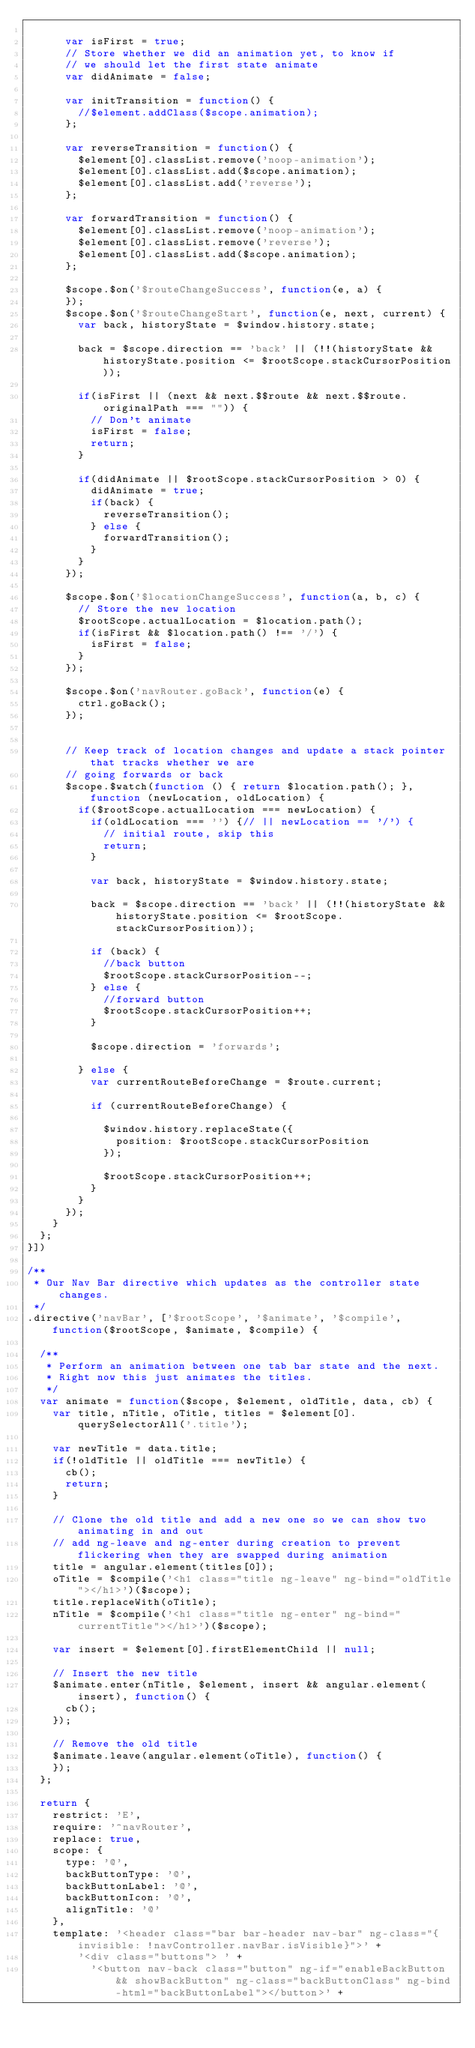Convert code to text. <code><loc_0><loc_0><loc_500><loc_500><_JavaScript_>
      var isFirst = true;
      // Store whether we did an animation yet, to know if
      // we should let the first state animate
      var didAnimate = false;

      var initTransition = function() {
        //$element.addClass($scope.animation);
      };

      var reverseTransition = function() {
        $element[0].classList.remove('noop-animation');
        $element[0].classList.add($scope.animation);
        $element[0].classList.add('reverse');
      };

      var forwardTransition = function() {
        $element[0].classList.remove('noop-animation');
        $element[0].classList.remove('reverse');
        $element[0].classList.add($scope.animation);
      };

      $scope.$on('$routeChangeSuccess', function(e, a) {
      });
      $scope.$on('$routeChangeStart', function(e, next, current) {
        var back, historyState = $window.history.state;

        back = $scope.direction == 'back' || (!!(historyState && historyState.position <= $rootScope.stackCursorPosition));

        if(isFirst || (next && next.$$route && next.$$route.originalPath === "")) {
          // Don't animate
          isFirst = false;
          return;
        }

        if(didAnimate || $rootScope.stackCursorPosition > 0) {
          didAnimate = true;
          if(back) {
            reverseTransition();
          } else {
            forwardTransition();
          }
        }
      });

      $scope.$on('$locationChangeSuccess', function(a, b, c) {
        // Store the new location
        $rootScope.actualLocation = $location.path();
        if(isFirst && $location.path() !== '/') {
          isFirst = false;
        }
      });  

      $scope.$on('navRouter.goBack', function(e) {
        ctrl.goBack();
      });


      // Keep track of location changes and update a stack pointer that tracks whether we are
      // going forwards or back
      $scope.$watch(function () { return $location.path(); }, function (newLocation, oldLocation) {
        if($rootScope.actualLocation === newLocation) {
          if(oldLocation === '') {// || newLocation == '/') {
            // initial route, skip this
            return;
          }

          var back, historyState = $window.history.state;

          back = $scope.direction == 'back' || (!!(historyState && historyState.position <= $rootScope.stackCursorPosition));

          if (back) {
            //back button
            $rootScope.stackCursorPosition--;
          } else {
            //forward button
            $rootScope.stackCursorPosition++;
          }
           
          $scope.direction = 'forwards';

        } else {
          var currentRouteBeforeChange = $route.current;

          if (currentRouteBeforeChange) {

            $window.history.replaceState({
              position: $rootScope.stackCursorPosition
            });

            $rootScope.stackCursorPosition++;
          }
        }
      });
    }
  };
}])

/**
 * Our Nav Bar directive which updates as the controller state changes.
 */
.directive('navBar', ['$rootScope', '$animate', '$compile', function($rootScope, $animate, $compile) {

  /**
   * Perform an animation between one tab bar state and the next.
   * Right now this just animates the titles.
   */
  var animate = function($scope, $element, oldTitle, data, cb) {
    var title, nTitle, oTitle, titles = $element[0].querySelectorAll('.title');

    var newTitle = data.title;
    if(!oldTitle || oldTitle === newTitle) {
      cb();
      return;
    }

    // Clone the old title and add a new one so we can show two animating in and out
    // add ng-leave and ng-enter during creation to prevent flickering when they are swapped during animation
    title = angular.element(titles[0]);
    oTitle = $compile('<h1 class="title ng-leave" ng-bind="oldTitle"></h1>')($scope);
    title.replaceWith(oTitle);
    nTitle = $compile('<h1 class="title ng-enter" ng-bind="currentTitle"></h1>')($scope);

    var insert = $element[0].firstElementChild || null;

    // Insert the new title
    $animate.enter(nTitle, $element, insert && angular.element(insert), function() {
      cb();
    });

    // Remove the old title
    $animate.leave(angular.element(oTitle), function() {
    });
  };

  return {
    restrict: 'E',
    require: '^navRouter',
    replace: true,
    scope: {
      type: '@',
      backButtonType: '@',
      backButtonLabel: '@',
      backButtonIcon: '@',
      alignTitle: '@'
    },
    template: '<header class="bar bar-header nav-bar" ng-class="{invisible: !navController.navBar.isVisible}">' + 
        '<div class="buttons"> ' +
          '<button nav-back class="button" ng-if="enableBackButton && showBackButton" ng-class="backButtonClass" ng-bind-html="backButtonLabel"></button>' +</code> 